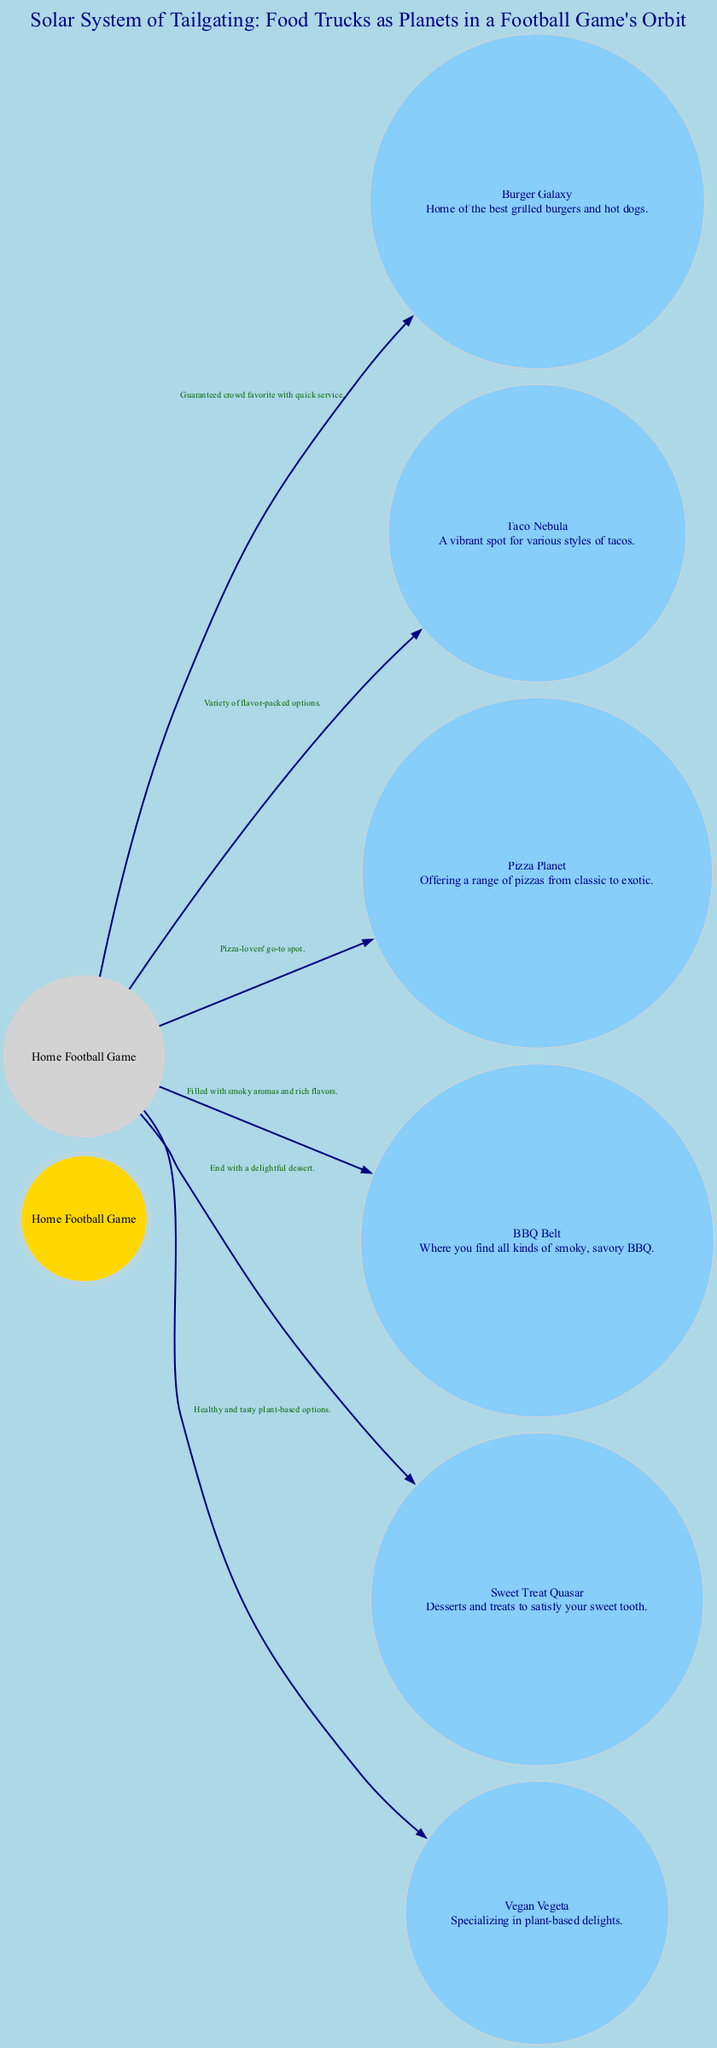What is at the center of the diagram? The central node in the diagram is labeled "Home Football Game," indicating it is the main event around which everything revolves.
Answer: Home Football Game How many food trucks are represented as planets in the diagram? There are six food trucks represented as planets: Burger Galaxy, Taco Nebula, Pizza Planet, BBQ Belt, Sweet Treat Quasar, and Vegan Vegeta. The central node does not count as a planet.
Answer: 6 Which food truck is described as a "crowd favorite with quick service"? The orbit connecting the Home Football Game to the Burger Galaxy describes it as a "Guaranteed crowd favorite with quick service."
Answer: Burger Galaxy What type of food does the Sweet Treat Quasar offer? The Sweet Treat Quasar is described as "Desserts and treats to satisfy your sweet tooth," indicating it offers sweet food options.
Answer: Desserts and treats Which planet specializes in plant-based delights? The Vegan Vegeta planet is described as "Specializing in plant-based delights," identifying it clearly as the planet for vegan options.
Answer: Vegan Vegeta How many orbits connect the Home Football Game to the food trucks? There are six orbits connecting the Home Football Game to each of the six food trucks: one for each planet listed in the diagram, totaling six orbits.
Answer: 6 Which food truck offers "a range of pizzas from classic to exotic"? The Pizza Planet is described as "Offering a range of pizzas from classic to exotic," making it clear that this is the indicated food truck.
Answer: Pizza Planet What does the BBQ Belt offer according to its description? The BBQ Belt is described as "Where you find all kinds of smoky, savory BBQ," indicating the type of food it offers.
Answer: Smoky, savory BBQ Which orbit includes "variety of flavor-packed options"? The orbit from Home Football Game to Taco Nebula includes the description "Variety of flavor-packed options," highlighting what this food truck represents.
Answer: Taco Nebula 